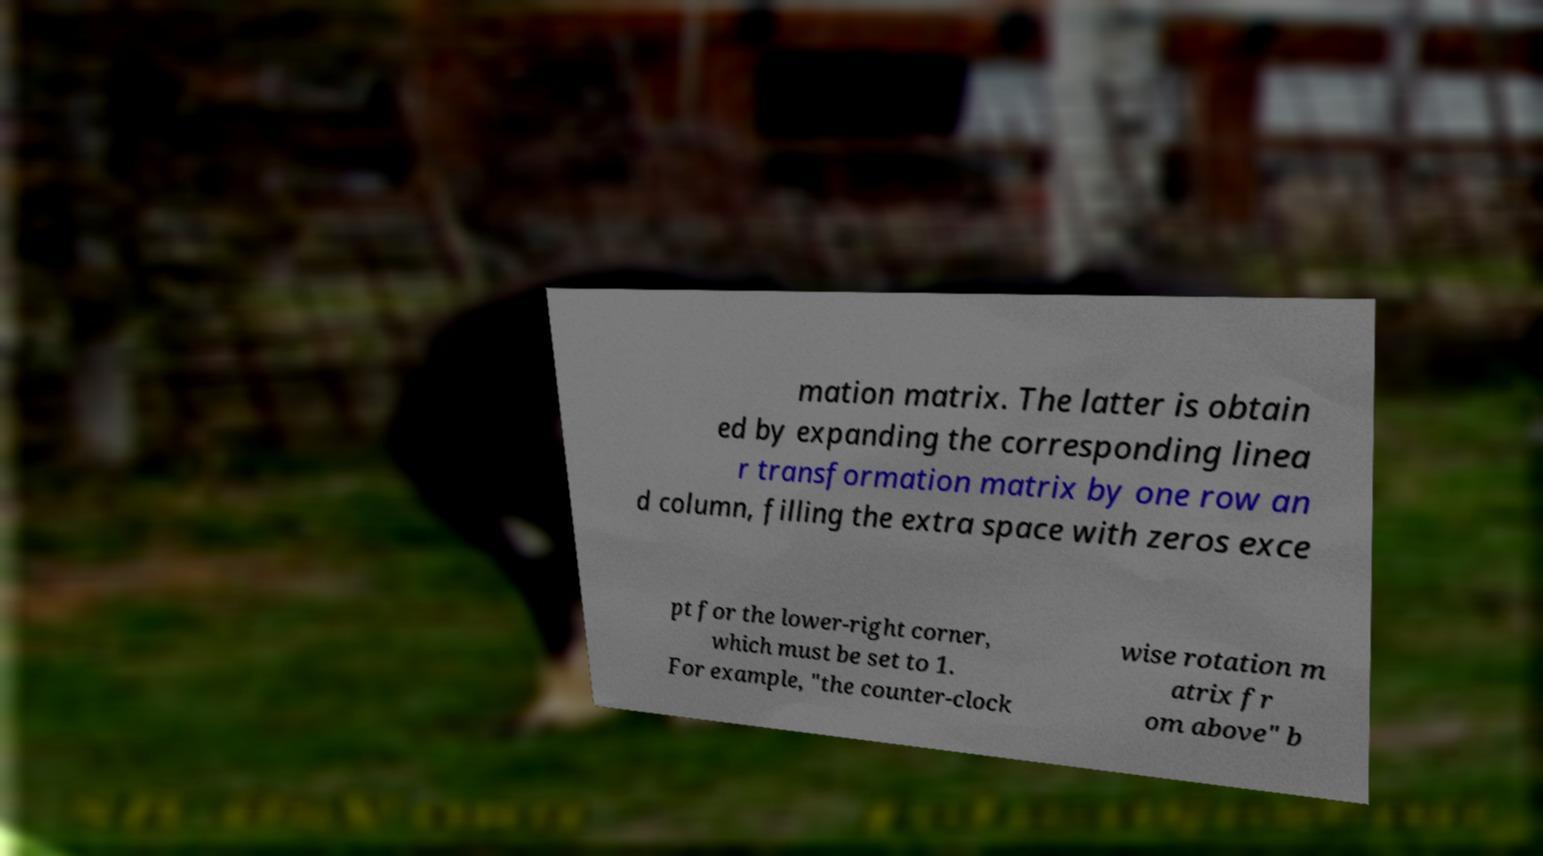Please identify and transcribe the text found in this image. mation matrix. The latter is obtain ed by expanding the corresponding linea r transformation matrix by one row an d column, filling the extra space with zeros exce pt for the lower-right corner, which must be set to 1. For example, "the counter-clock wise rotation m atrix fr om above" b 